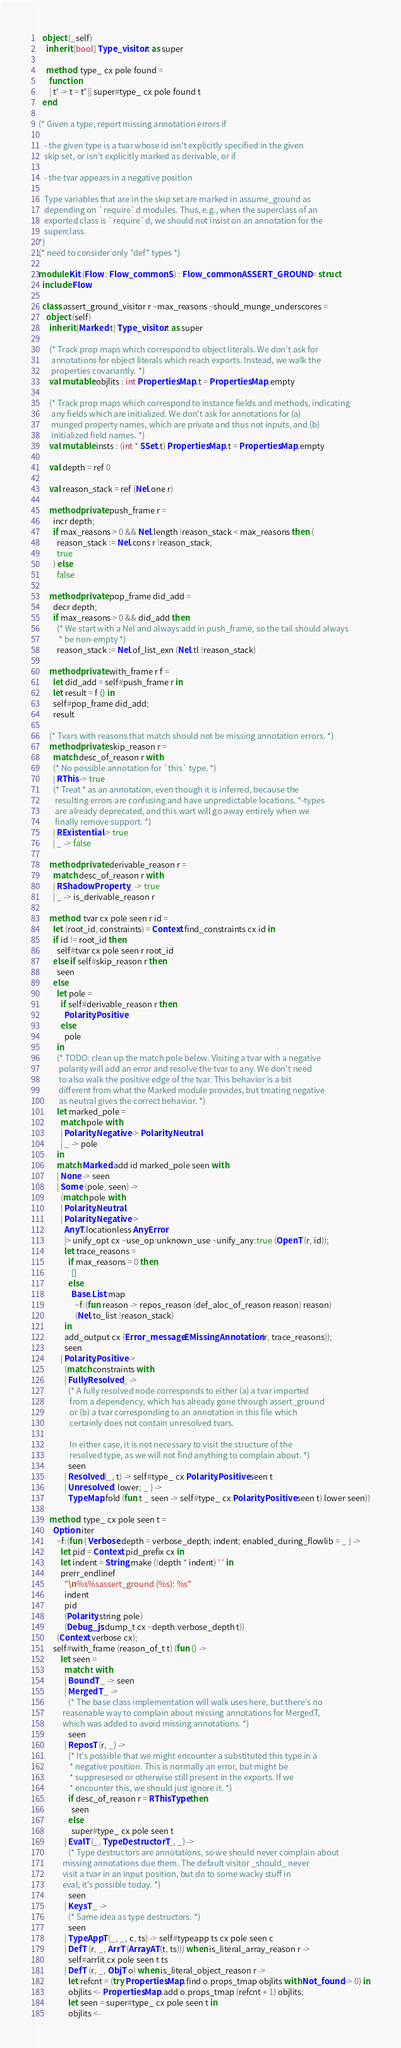<code> <loc_0><loc_0><loc_500><loc_500><_OCaml_>  object (_self)
    inherit [bool] Type_visitor.t as super

    method! type_ cx pole found =
      function
      | t' -> t = t' || super#type_ cx pole found t
  end

(* Given a type, report missing annotation errors if

   - the given type is a tvar whose id isn't explicitly specified in the given
   skip set, or isn't explicitly marked as derivable, or if

   - the tvar appears in a negative position

   Type variables that are in the skip set are marked in assume_ground as
   depending on `require`d modules. Thus, e.g., when the superclass of an
   exported class is `require`d, we should not insist on an annotation for the
   superclass.
*)
(* need to consider only "def" types *)

module Kit (Flow : Flow_common.S) : Flow_common.ASSERT_GROUND = struct
  include Flow

  class assert_ground_visitor r ~max_reasons ~should_munge_underscores =
    object (self)
      inherit [Marked.t] Type_visitor.t as super

      (* Track prop maps which correspond to object literals. We don't ask for
       annotations for object literals which reach exports. Instead, we walk the
       properties covariantly. *)
      val mutable objlits : int Properties.Map.t = Properties.Map.empty

      (* Track prop maps which correspond to instance fields and methods, indicating
       any fields which are initialized. We don't ask for annotations for (a)
       munged property names, which are private and thus not inputs, and (b)
       initialized field names. *)
      val mutable insts : (int * SSet.t) Properties.Map.t = Properties.Map.empty

      val depth = ref 0

      val reason_stack = ref (Nel.one r)

      method private push_frame r =
        incr depth;
        if max_reasons > 0 && Nel.length !reason_stack < max_reasons then (
          reason_stack := Nel.cons r !reason_stack;
          true
        ) else
          false

      method private pop_frame did_add =
        decr depth;
        if max_reasons > 0 && did_add then
          (* We start with a Nel and always add in push_frame, so the tail should always
           * be non-empty *)
          reason_stack := Nel.of_list_exn (Nel.tl !reason_stack)

      method private with_frame r f =
        let did_add = self#push_frame r in
        let result = f () in
        self#pop_frame did_add;
        result

      (* Tvars with reasons that match should not be missing annotation errors. *)
      method private skip_reason r =
        match desc_of_reason r with
        (* No possible annotation for `this` type. *)
        | RThis -> true
        (* Treat * as an annotation, even though it is inferred, because the
         resulting errors are confusing and have unpredictable locations. *-types
         are already deprecated, and this wart will go away entirely when we
         finally remove support. *)
        | RExistential -> true
        | _ -> false

      method private derivable_reason r =
        match desc_of_reason r with
        | RShadowProperty _ -> true
        | _ -> is_derivable_reason r

      method! tvar cx pole seen r id =
        let (root_id, constraints) = Context.find_constraints cx id in
        if id != root_id then
          self#tvar cx pole seen r root_id
        else if self#skip_reason r then
          seen
        else
          let pole =
            if self#derivable_reason r then
              Polarity.Positive
            else
              pole
          in
          (* TODO: clean up the match pole below. Visiting a tvar with a negative
           polarity will add an error and resolve the tvar to any. We don't need
           to also walk the positive edge of the tvar. This behavior is a bit
           different from what the Marked module provides, but treating negative
           as neutral gives the correct behavior. *)
          let marked_pole =
            match pole with
            | Polarity.Negative -> Polarity.Neutral
            | _ -> pole
          in
          match Marked.add id marked_pole seen with
          | None -> seen
          | Some (pole, seen) ->
            (match pole with
            | Polarity.Neutral
            | Polarity.Negative ->
              AnyT.locationless AnyError
              |> unify_opt cx ~use_op:unknown_use ~unify_any:true (OpenT (r, id));
              let trace_reasons =
                if max_reasons = 0 then
                  []
                else
                  Base.List.map
                    ~f:(fun reason -> repos_reason (def_aloc_of_reason reason) reason)
                    (Nel.to_list !reason_stack)
              in
              add_output cx (Error_message.EMissingAnnotation (r, trace_reasons));
              seen
            | Polarity.Positive ->
              (match constraints with
              | FullyResolved _ ->
                (* A fully resolved node corresponds to either (a) a tvar imported
                 from a dependency, which has already gone through assert_ground
                 or (b) a tvar corresponding to an annotation in this file which
                 certainly does not contain unresolved tvars.

                 In either case, it is not necessary to visit the structure of the
                 resolved type, as we will not find anything to complain about. *)
                seen
              | Resolved (_, t) -> self#type_ cx Polarity.Positive seen t
              | Unresolved { lower; _ } ->
                TypeMap.fold (fun t _ seen -> self#type_ cx Polarity.Positive seen t) lower seen))

      method! type_ cx pole seen t =
        Option.iter
          ~f:(fun { Verbose.depth = verbose_depth; indent; enabled_during_flowlib = _ } ->
            let pid = Context.pid_prefix cx in
            let indent = String.make (!depth * indent) ' ' in
            prerr_endlinef
              "\n%s%sassert_ground (%s): %s"
              indent
              pid
              (Polarity.string pole)
              (Debug_js.dump_t cx ~depth:verbose_depth t))
          (Context.verbose cx);
        self#with_frame (reason_of_t t) (fun () ->
            let seen =
              match t with
              | BoundT _ -> seen
              | MergedT _ ->
                (* The base class implementation will walk uses here, but there's no
             reasonable way to complain about missing annotations for MergedT,
             which was added to avoid missing annotations. *)
                seen
              | ReposT (r, _) ->
                (* It's possible that we might encounter a substituted this type in a
                 * negative position. This is normally an error, but might be
                 * suppresesed or otherwise still present in the exports. If we
                 * encounter this, we should just ignore it. *)
                if desc_of_reason r = RThisType then
                  seen
                else
                  super#type_ cx pole seen t
              | EvalT (_, TypeDestructorT _, _) ->
                (* Type destructors are annotations, so we should never complain about
             missing annotations due them. The default visitor _should_ never
             visit a tvar in an input position, but do to some wacky stuff in
             eval, it's possible today. *)
                seen
              | KeysT _ ->
                (* Same idea as type destructors. *)
                seen
              | TypeAppT (_, _, c, ts) -> self#typeapp ts cx pole seen c
              | DefT (r, _, ArrT (ArrayAT (t, ts))) when is_literal_array_reason r ->
                self#arrlit cx pole seen t ts
              | DefT (r, _, ObjT o) when is_literal_object_reason r ->
                let refcnt = (try Properties.Map.find o.props_tmap objlits with Not_found -> 0) in
                objlits <- Properties.Map.add o.props_tmap (refcnt + 1) objlits;
                let seen = super#type_ cx pole seen t in
                objlits <-</code> 